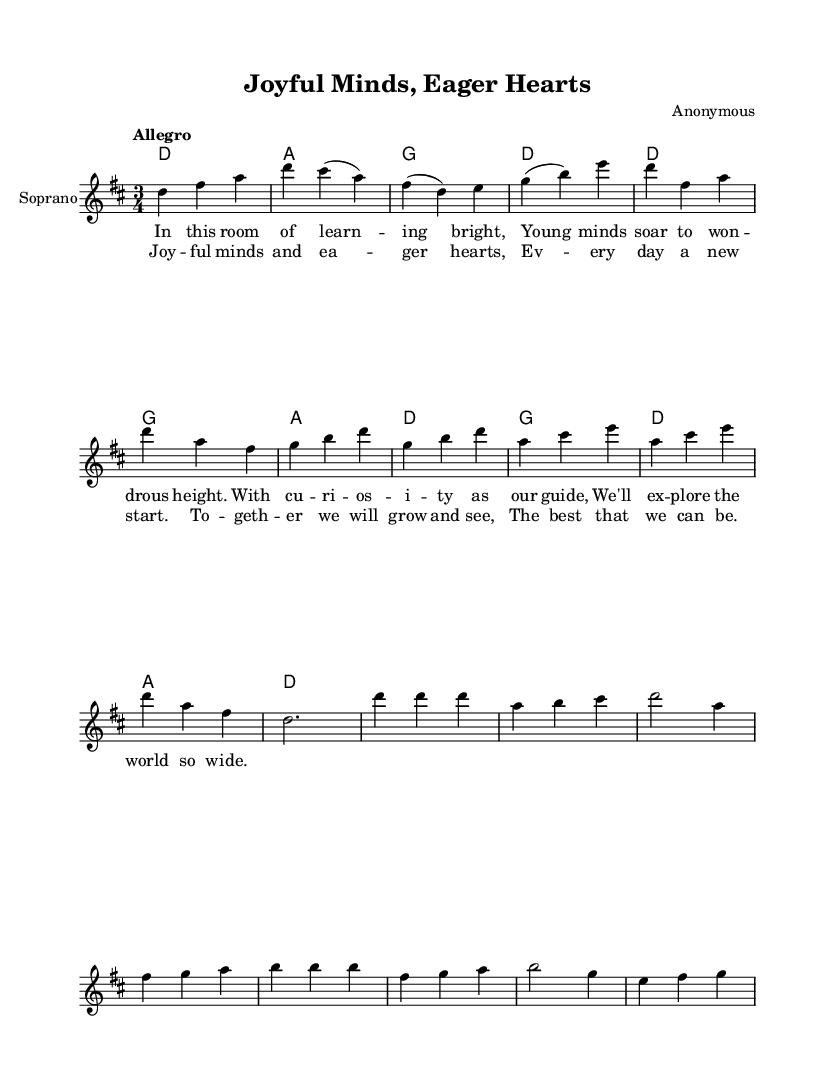What is the key signature of this music? The key signature is D major, which has two sharps (F# and C#). This can be identified by looking at the beginning of the staff where the sharps are indicated.
Answer: D major What is the time signature of this music? The time signature is 3/4, which means there are three beats in each measure and the quarter note receives one beat. This information is found at the beginning of the score after the key signature.
Answer: 3/4 What is the tempo marking for this piece? The tempo marking is "Allegro," which indicates a fast and lively tempo. This is noted in the score next to the tempo indication at the start.
Answer: Allegro How many measures are there in the chorus? The chorus has eight measures, which can be counted by examining the segments of music that contain the lyric line under the music. Each grouping corresponds to one measure.
Answer: Eight What is the highest note in the soprano part? The highest note in the soprano part is D, which can be identified by looking at the relative pitches in the melody line and locating the highest pitch notated.
Answer: D What vocal texture is used in this piece? The vocal texture is solo soprano, as indicated by the notation on the staff and the absence of additional vocal parts or harmonies specifically for other voices.
Answer: Solo soprano What is the main theme or message conveyed in the lyrics? The main theme of the lyrics focuses on learning and growth, which is evident from the phrases about young minds and collective progress. This can be interpreted by analyzing the overall sentiment expressed in the lyrics provided.
Answer: Learning and growth 